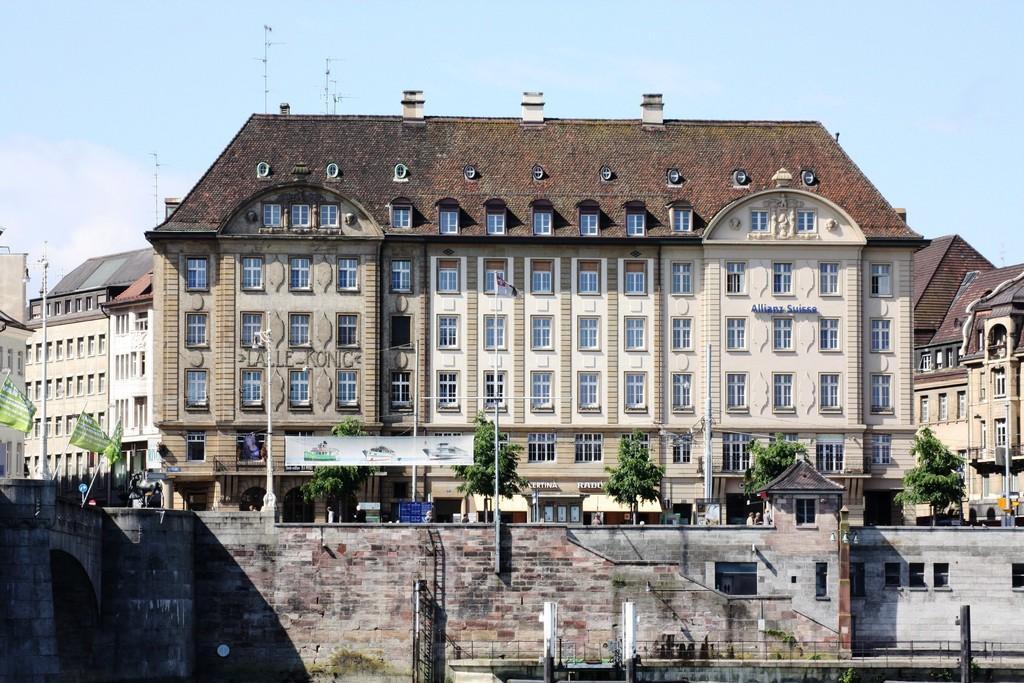Please provide a concise description of this image. In this image there is a building in the middle. At the bottom there is a wall. On the left side it seems like a bridge. In front of the building there is a road on which there are few poles and few people. There are trees on the footpath. At the top there is the sky. There are few other buildings beside the building. On the left side there are flags. 